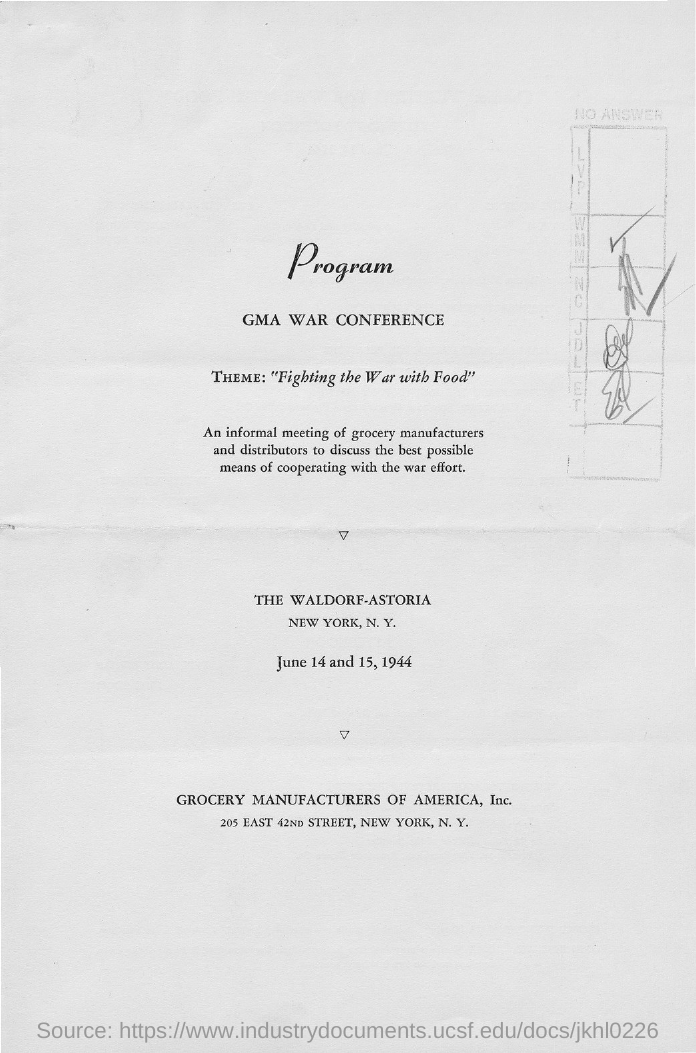Draw attention to some important aspects in this diagram. The theme of the conference is "Fighting the war with Food," which highlights the importance of addressing the ongoing conflict through sustainable food practices and strategies. The conference will take place on June 14 and 15, 1944. The GMA War Conference is the conference. 